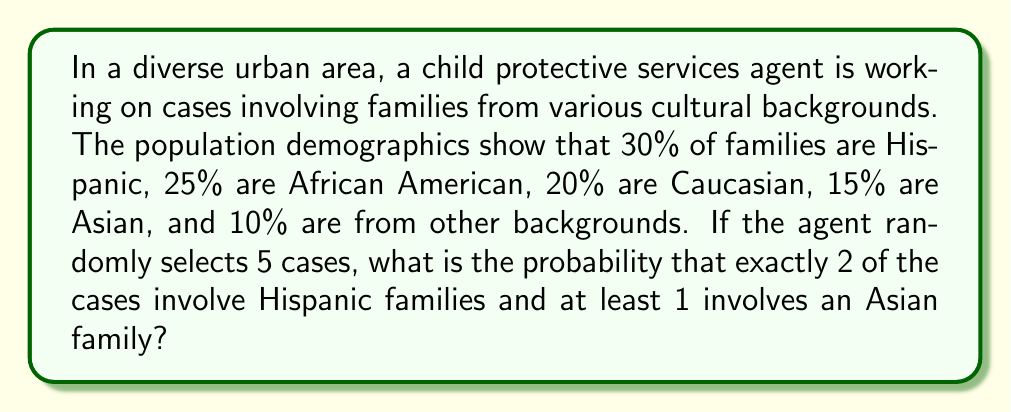Can you solve this math problem? To solve this problem, we'll use the concepts of binomial probability and complement of events. Let's break it down step-by-step:

1) First, let's calculate the probability of exactly 2 Hispanic cases out of 5:
   We use the binomial probability formula:
   $$P(X = k) = \binom{n}{k} p^k (1-p)^{n-k}$$
   Where $n = 5$, $k = 2$, and $p = 0.30$
   
   $$P(2 \text{ Hispanic}) = \binom{5}{2} (0.30)^2 (0.70)^3 = 10 \cdot 0.09 \cdot 0.343 = 0.3087$$

2) Now, for at least 1 Asian case, it's easier to calculate the probability of no Asian cases and subtract from 1:
   $$P(\text{at least 1 Asian}) = 1 - P(\text{no Asian})$$
   $$= 1 - (0.85)^5 = 1 - 0.4437 = 0.5563$$

3) These events are independent, so we multiply the probabilities:
   $$P(2 \text{ Hispanic AND at least 1 Asian}) = 0.3087 \cdot 0.5563 = 0.1718$$

Therefore, the probability is approximately 0.1718 or 17.18%.
Answer: 0.1718 or 17.18% 